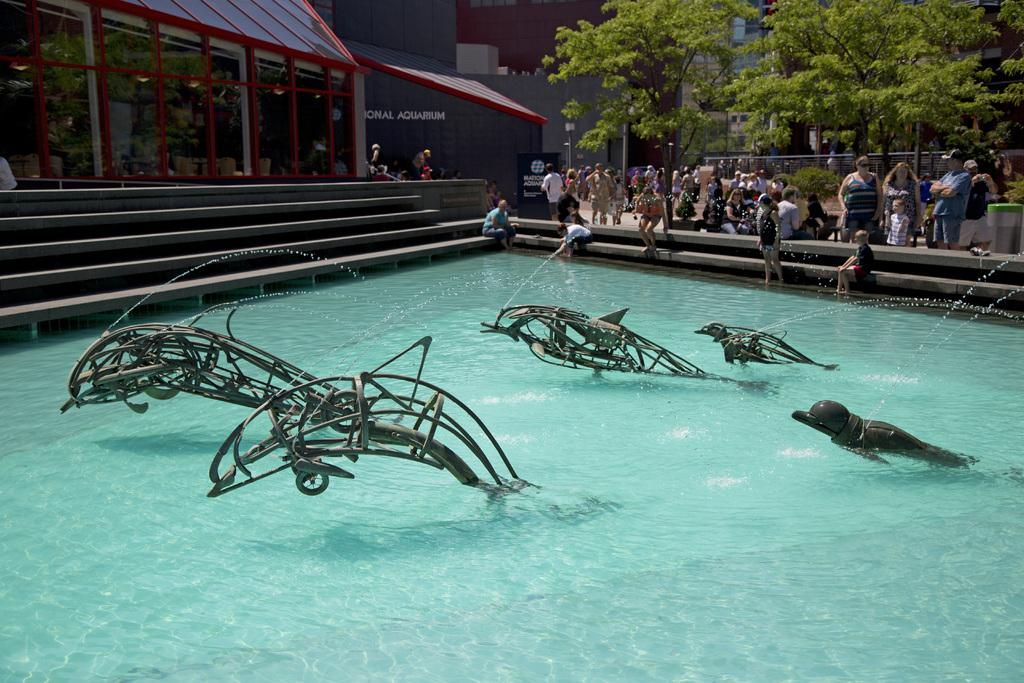What is the main subject in the middle of the image? There is a pool in the middle of the image. What are the persons in the image doing? The persons are in the pool. What can be seen in the background of the image? There are trees visible at the top of the image. Where is the queen sitting in the image? There is no queen present in the image. What type of flower can be seen growing near the pool? There is no flower present in the image. 